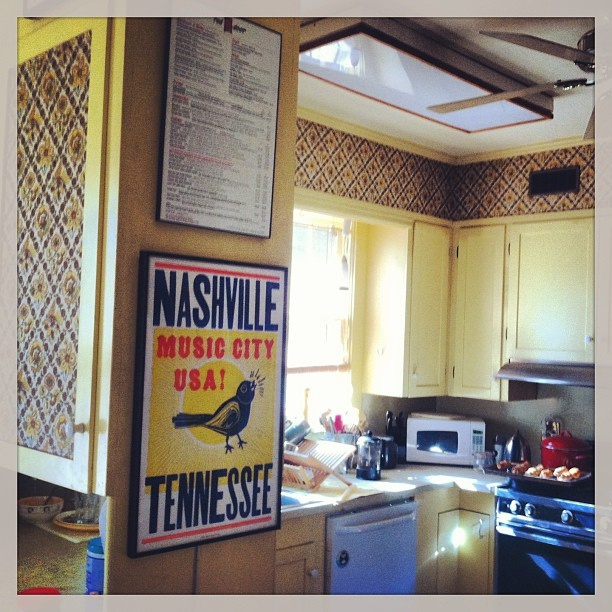Describe the objects in this image and their specific colors. I can see oven in lightgray, black, navy, blue, and white tones, microwave in lightgray, darkgray, navy, and lavender tones, bowl in lightgray, black, and gray tones, and sink in lightgray, white, lightblue, and darkgray tones in this image. 